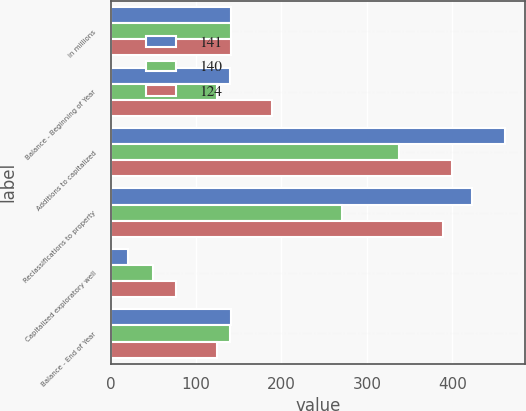Convert chart to OTSL. <chart><loc_0><loc_0><loc_500><loc_500><stacked_bar_chart><ecel><fcel>in millions<fcel>Balance - Beginning of Year<fcel>Additions to capitalized<fcel>Reclassifications to property<fcel>Capitalized exploratory well<fcel>Balance - End of Year<nl><fcel>141<fcel>141<fcel>140<fcel>462<fcel>423<fcel>21<fcel>141<nl><fcel>140<fcel>141<fcel>124<fcel>337<fcel>271<fcel>50<fcel>140<nl><fcel>124<fcel>141<fcel>189<fcel>400<fcel>389<fcel>76<fcel>124<nl></chart> 